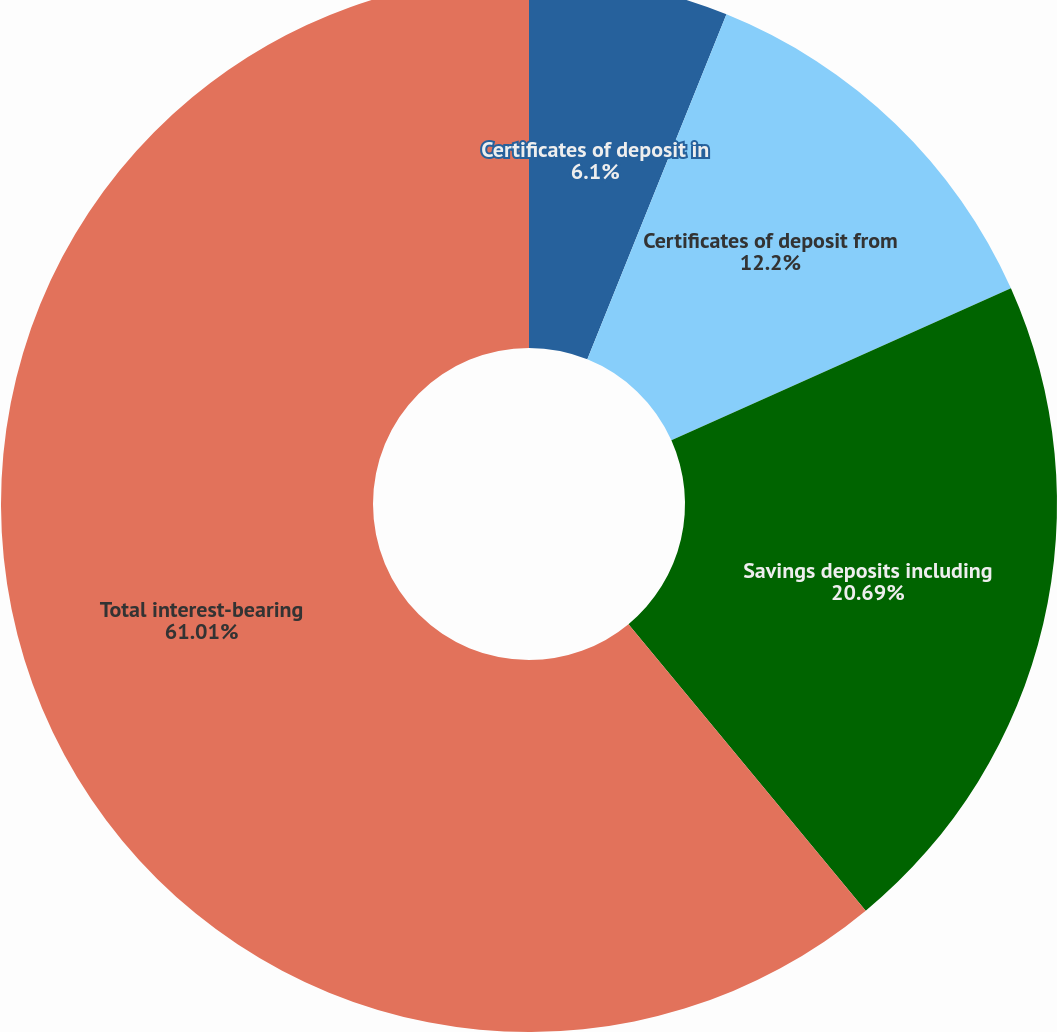<chart> <loc_0><loc_0><loc_500><loc_500><pie_chart><fcel>Certificates of deposit in<fcel>Certificates of deposit from<fcel>Savings deposits including<fcel>Total interest-bearing<fcel>Average annual interest rate<nl><fcel>6.1%<fcel>12.2%<fcel>20.69%<fcel>61.0%<fcel>0.0%<nl></chart> 